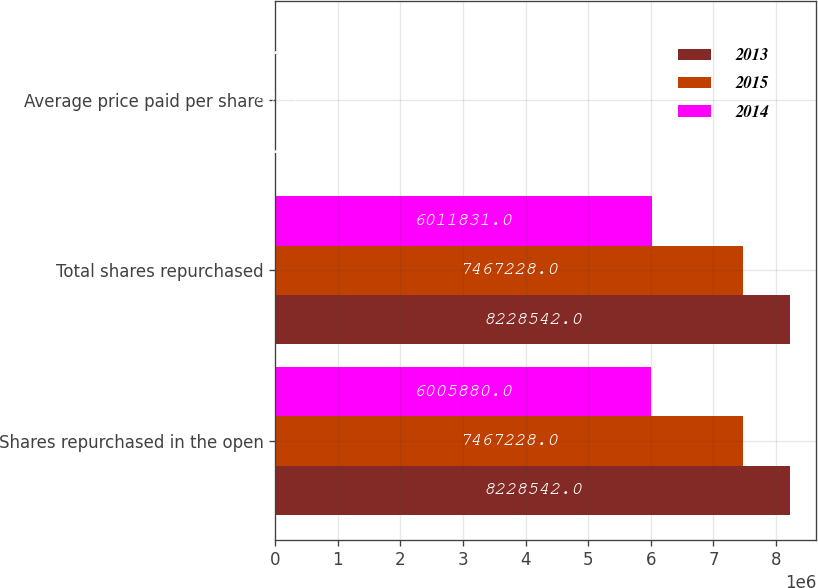Convert chart. <chart><loc_0><loc_0><loc_500><loc_500><stacked_bar_chart><ecel><fcel>Shares repurchased in the open<fcel>Total shares repurchased<fcel>Average price paid per share<nl><fcel>2013<fcel>8.22854e+06<fcel>8.22854e+06<fcel>72.94<nl><fcel>2015<fcel>7.46723e+06<fcel>7.46723e+06<fcel>80.5<nl><fcel>2014<fcel>6.00588e+06<fcel>6.01183e+06<fcel>76.16<nl></chart> 